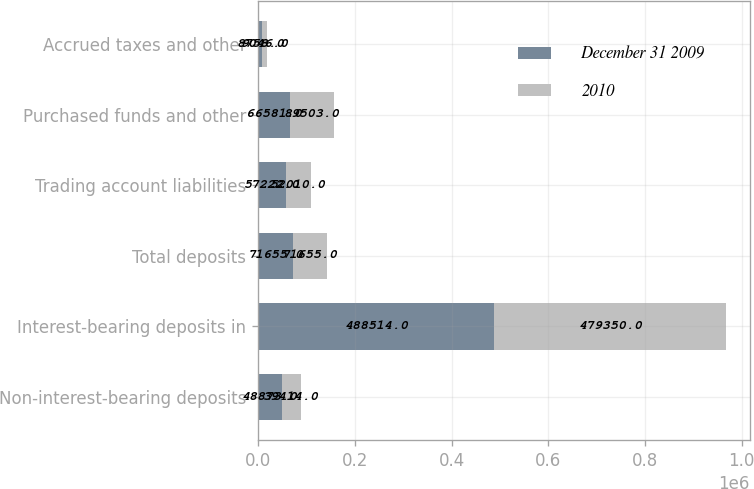Convert chart. <chart><loc_0><loc_0><loc_500><loc_500><stacked_bar_chart><ecel><fcel>Non-interest-bearing deposits<fcel>Interest-bearing deposits in<fcel>Total deposits<fcel>Trading account liabilities<fcel>Purchased funds and other<fcel>Accrued taxes and other<nl><fcel>December 31 2009<fcel>48873<fcel>488514<fcel>71655<fcel>57222<fcel>66581<fcel>8758<nl><fcel>2010<fcel>39414<fcel>479350<fcel>71655<fcel>52010<fcel>89503<fcel>9046<nl></chart> 